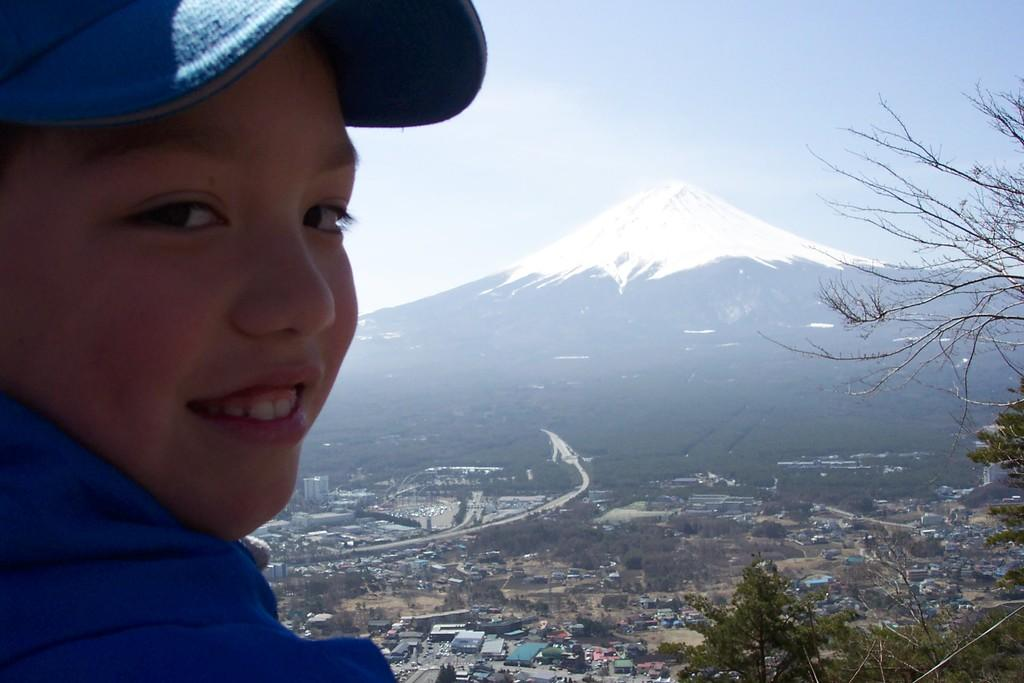Who or what is present in the image? There is a person in the image. What is the person's facial expression? The person is smiling. What can be seen in the background of the image? There are buildings, trees, vehicles, and a mountain in the background of the image. What part of the natural environment is visible in the image? The sky is visible at the top of the image. What type of trousers is the dog wearing in the image? There is no dog present in the image, and therefore no trousers can be observed. What shape does the circle take in the image? There is no circle present in the image. 